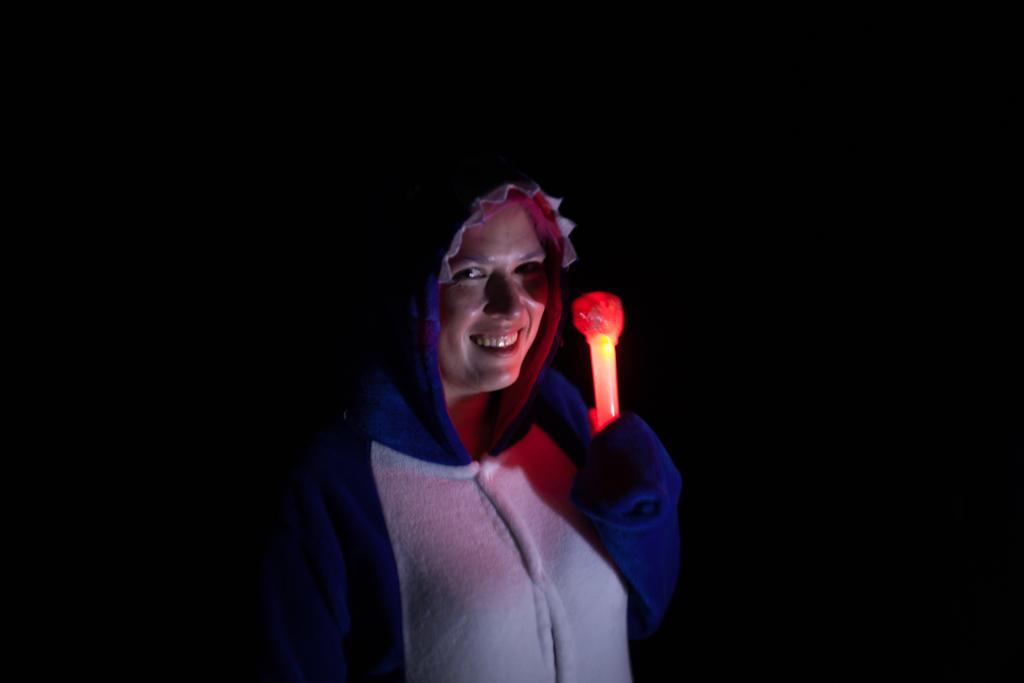What can be observed about the person's facial expression in the image? The person has a smiling face in the image. What is the person's posture in the image? The person is standing in the image. What is the person holding in the image? The person is holding an object in the image. How would you describe the lighting or color of the background in the image? The background of the image is dark. What type of ornament is hanging from the person's ear in the image? There is no ornament visible on the person's ear in the image. How does the person transport themselves to their destination in the image? The image does not show the person in motion or provide any information about their mode of transportation. 